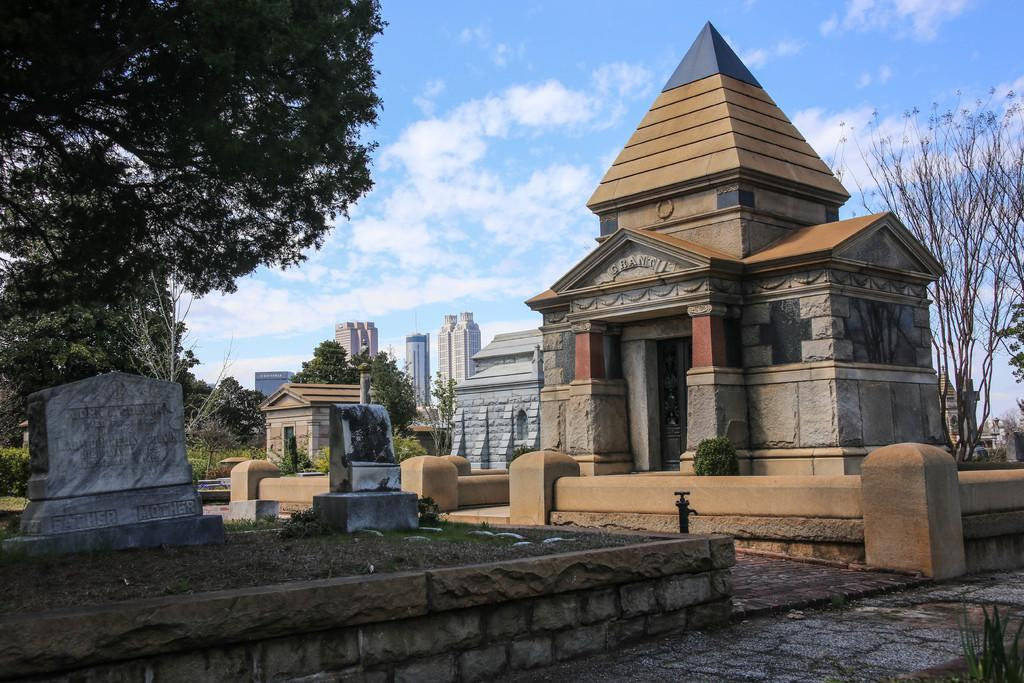What is the main subject in the center of the image? There is a monument in the center of the image. What can be seen in the background of the image? There are buildings in the background of the image. What type of vegetation is present in the image? There are trees in the image. What type of book can be seen on the monument in the image? There is no book present on the monument in the image. What kind of music is being played by the trees in the image? There is no music being played by the trees in the image. 